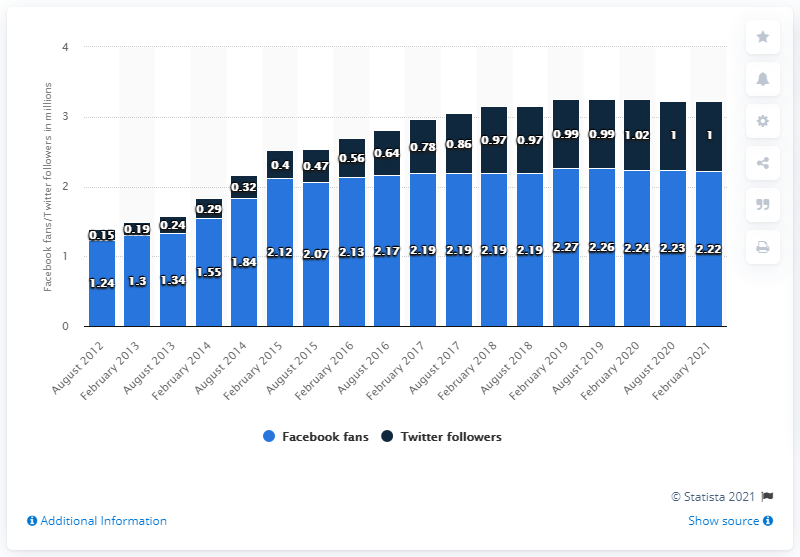Mention a couple of crucial points in this snapshot. As of February 2021, the Miami Dolphins football team had approximately 2.22 million Facebook followers. 